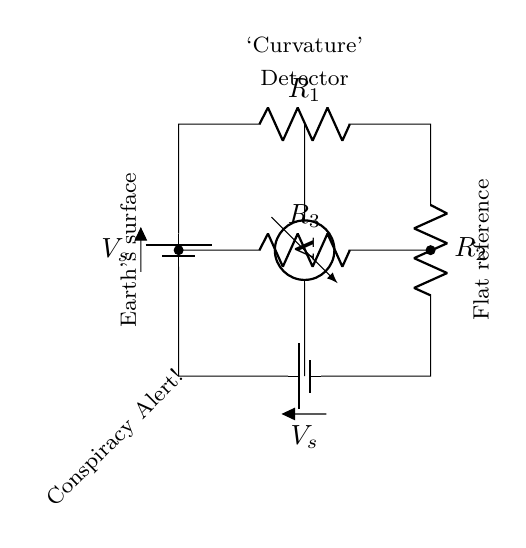What are the resistors in this circuit? The circuit diagram shows three resistors labeled as R1, R2, and R3. These are the components designed to measure resistance in the bridge configuration.
Answer: R1, R2, R3 What do the batteries represent? The two batteries in the circuit are labeled V_s, indicating they are sources of voltage supplying power to the circuit. In this case, they contribute to the measurement of voltage across the resistors.
Answer: Voltage sources What is the purpose of the voltmeter in this circuit? The voltmeter is connected between the upper and lower horizontal parts of the Wheatstone bridge, measuring the potential difference across R3. This provides information on whether the circuit is balanced or not, indicating curvature.
Answer: Measurement of potential difference Is this circuit balanced? The circuit is considered balanced when the voltage across the voltmeter is zero. In this diagram, without additional numerical data, visual inspection does not provide information about balance; therefore, we cannot definitively say it is balanced.
Answer: Cannot determine What is indicated by the label "Curvature Detector"? The label suggests that this Wheatstone bridge is utilized to detect variations in curvature, specifically indicating how this circuit might relate to assessing the curvature of the Earth's surface or a reference plane.
Answer: Measurement of curvature How are the resistors connected in this Wheatstone bridge? The resistors are arranged in a series-parallel configuration typical of a Wheatstone bridge. R1 and R2 are in series with the voltage source, while R3 is in parallel between the two nodes created by the series combination, allowing for comparison of resistance.
Answer: Series-parallel 